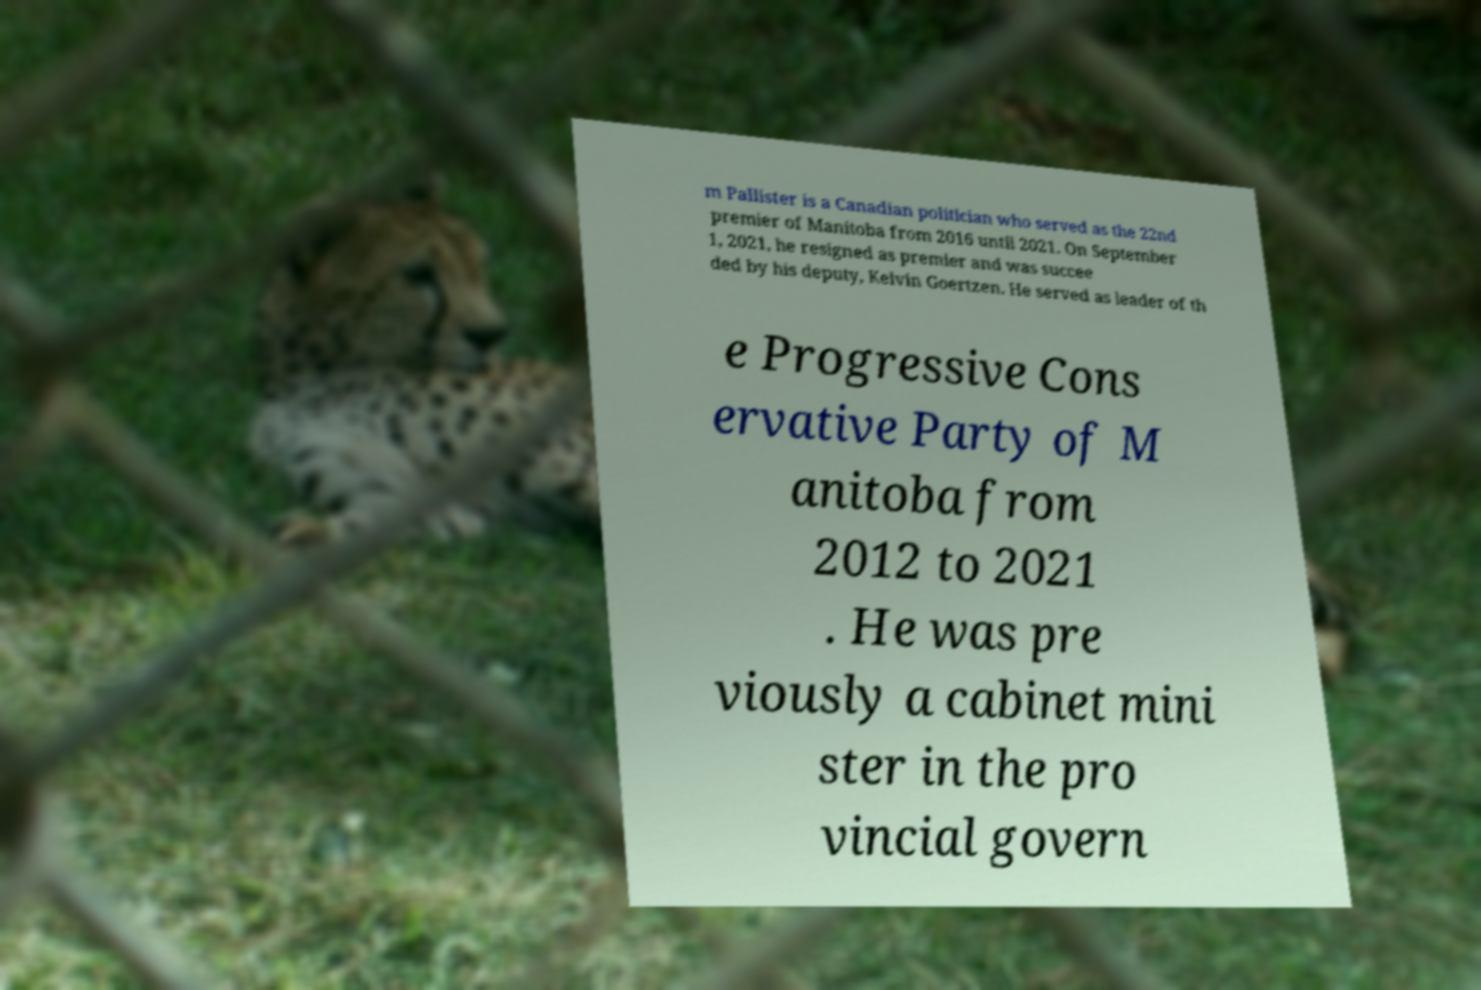What messages or text are displayed in this image? I need them in a readable, typed format. m Pallister is a Canadian politician who served as the 22nd premier of Manitoba from 2016 until 2021. On September 1, 2021, he resigned as premier and was succee ded by his deputy, Kelvin Goertzen. He served as leader of th e Progressive Cons ervative Party of M anitoba from 2012 to 2021 . He was pre viously a cabinet mini ster in the pro vincial govern 